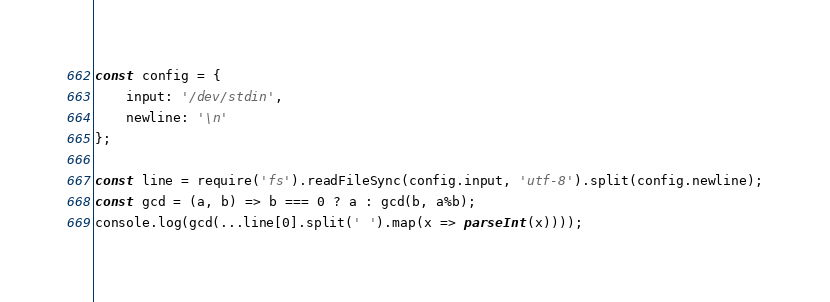Convert code to text. <code><loc_0><loc_0><loc_500><loc_500><_JavaScript_>const config = {
    input: '/dev/stdin',
    newline: '\n'
};

const line = require('fs').readFileSync(config.input, 'utf-8').split(config.newline);
const gcd = (a, b) => b === 0 ? a : gcd(b, a%b);
console.log(gcd(...line[0].split(' ').map(x => parseInt(x))));
</code> 